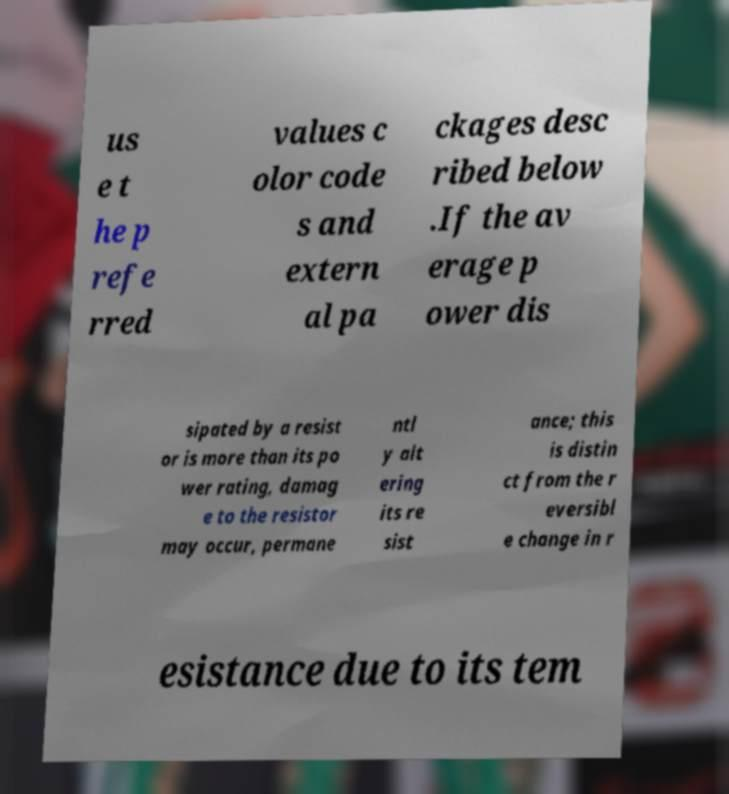For documentation purposes, I need the text within this image transcribed. Could you provide that? us e t he p refe rred values c olor code s and extern al pa ckages desc ribed below .If the av erage p ower dis sipated by a resist or is more than its po wer rating, damag e to the resistor may occur, permane ntl y alt ering its re sist ance; this is distin ct from the r eversibl e change in r esistance due to its tem 